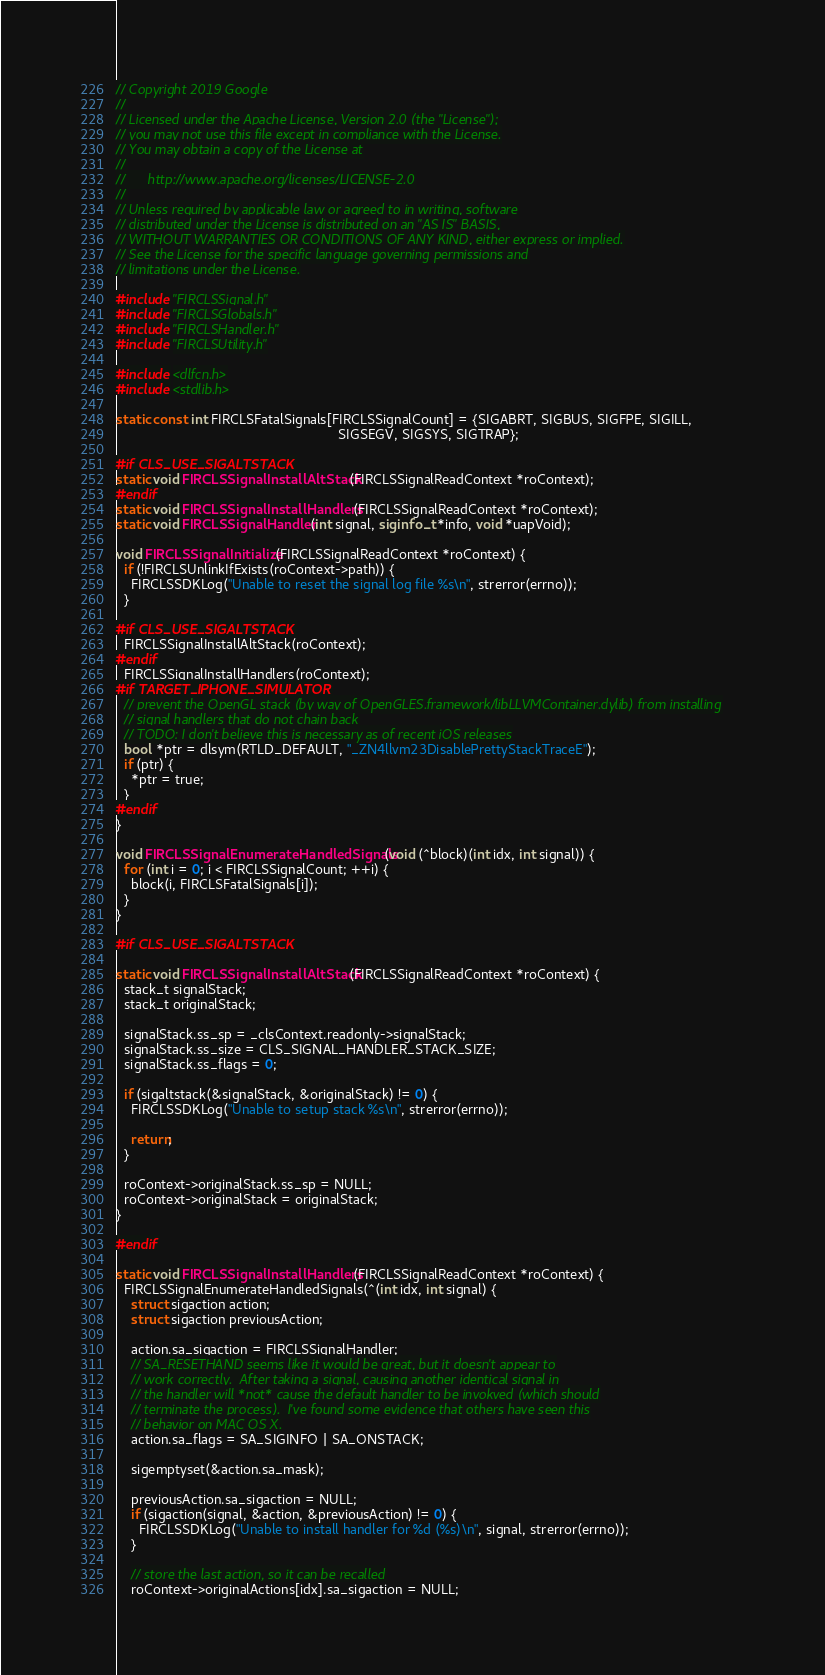Convert code to text. <code><loc_0><loc_0><loc_500><loc_500><_C_>// Copyright 2019 Google
//
// Licensed under the Apache License, Version 2.0 (the "License");
// you may not use this file except in compliance with the License.
// You may obtain a copy of the License at
//
//      http://www.apache.org/licenses/LICENSE-2.0
//
// Unless required by applicable law or agreed to in writing, software
// distributed under the License is distributed on an "AS IS" BASIS,
// WITHOUT WARRANTIES OR CONDITIONS OF ANY KIND, either express or implied.
// See the License for the specific language governing permissions and
// limitations under the License.

#include "FIRCLSSignal.h"
#include "FIRCLSGlobals.h"
#include "FIRCLSHandler.h"
#include "FIRCLSUtility.h"

#include <dlfcn.h>
#include <stdlib.h>

static const int FIRCLSFatalSignals[FIRCLSSignalCount] = {SIGABRT, SIGBUS, SIGFPE, SIGILL,
                                                          SIGSEGV, SIGSYS, SIGTRAP};

#if CLS_USE_SIGALTSTACK
static void FIRCLSSignalInstallAltStack(FIRCLSSignalReadContext *roContext);
#endif
static void FIRCLSSignalInstallHandlers(FIRCLSSignalReadContext *roContext);
static void FIRCLSSignalHandler(int signal, siginfo_t *info, void *uapVoid);

void FIRCLSSignalInitialize(FIRCLSSignalReadContext *roContext) {
  if (!FIRCLSUnlinkIfExists(roContext->path)) {
    FIRCLSSDKLog("Unable to reset the signal log file %s\n", strerror(errno));
  }

#if CLS_USE_SIGALTSTACK
  FIRCLSSignalInstallAltStack(roContext);
#endif
  FIRCLSSignalInstallHandlers(roContext);
#if TARGET_IPHONE_SIMULATOR
  // prevent the OpenGL stack (by way of OpenGLES.framework/libLLVMContainer.dylib) from installing
  // signal handlers that do not chain back
  // TODO: I don't believe this is necessary as of recent iOS releases
  bool *ptr = dlsym(RTLD_DEFAULT, "_ZN4llvm23DisablePrettyStackTraceE");
  if (ptr) {
    *ptr = true;
  }
#endif
}

void FIRCLSSignalEnumerateHandledSignals(void (^block)(int idx, int signal)) {
  for (int i = 0; i < FIRCLSSignalCount; ++i) {
    block(i, FIRCLSFatalSignals[i]);
  }
}

#if CLS_USE_SIGALTSTACK

static void FIRCLSSignalInstallAltStack(FIRCLSSignalReadContext *roContext) {
  stack_t signalStack;
  stack_t originalStack;

  signalStack.ss_sp = _clsContext.readonly->signalStack;
  signalStack.ss_size = CLS_SIGNAL_HANDLER_STACK_SIZE;
  signalStack.ss_flags = 0;

  if (sigaltstack(&signalStack, &originalStack) != 0) {
    FIRCLSSDKLog("Unable to setup stack %s\n", strerror(errno));

    return;
  }

  roContext->originalStack.ss_sp = NULL;
  roContext->originalStack = originalStack;
}

#endif

static void FIRCLSSignalInstallHandlers(FIRCLSSignalReadContext *roContext) {
  FIRCLSSignalEnumerateHandledSignals(^(int idx, int signal) {
    struct sigaction action;
    struct sigaction previousAction;

    action.sa_sigaction = FIRCLSSignalHandler;
    // SA_RESETHAND seems like it would be great, but it doesn't appear to
    // work correctly.  After taking a signal, causing another identical signal in
    // the handler will *not* cause the default handler to be invokved (which should
    // terminate the process).  I've found some evidence that others have seen this
    // behavior on MAC OS X.
    action.sa_flags = SA_SIGINFO | SA_ONSTACK;

    sigemptyset(&action.sa_mask);

    previousAction.sa_sigaction = NULL;
    if (sigaction(signal, &action, &previousAction) != 0) {
      FIRCLSSDKLog("Unable to install handler for %d (%s)\n", signal, strerror(errno));
    }

    // store the last action, so it can be recalled
    roContext->originalActions[idx].sa_sigaction = NULL;
</code> 